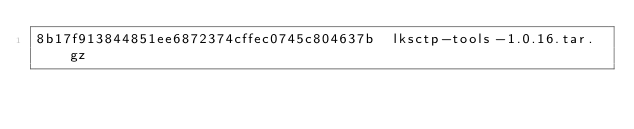<code> <loc_0><loc_0><loc_500><loc_500><_SML_>8b17f913844851ee6872374cffec0745c804637b  lksctp-tools-1.0.16.tar.gz
</code> 